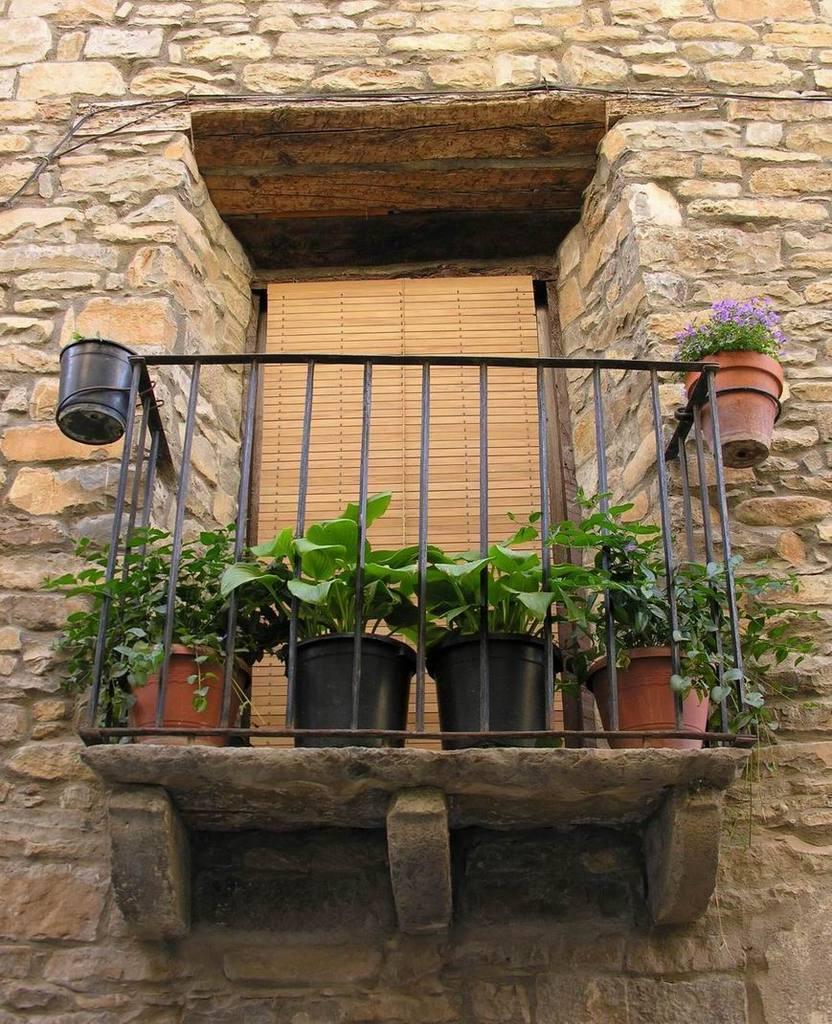In one or two sentences, can you explain what this image depicts? In this picture we can see house plants, railing, wall and some objects. 